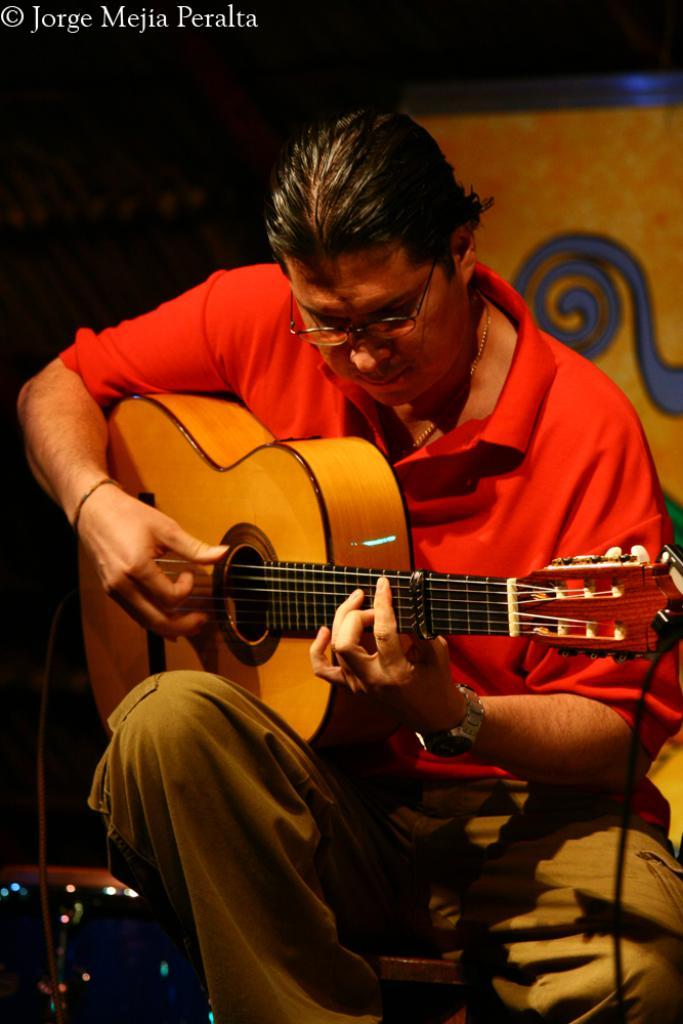Who is the person in the image? There is a man in the image. What is the man doing in the image? The man is sitting on a chair and playing the guitar. What is the man holding in the image? The man is holding a guitar. What can be seen in the background of the image? There is a yellow color hoarding in the background of the image. What type of sea creature can be seen swimming in the image? There is no sea creature present in the image; it features a man playing a guitar. Can you tell me how much blood is visible in the image? There is no blood visible in the image. 